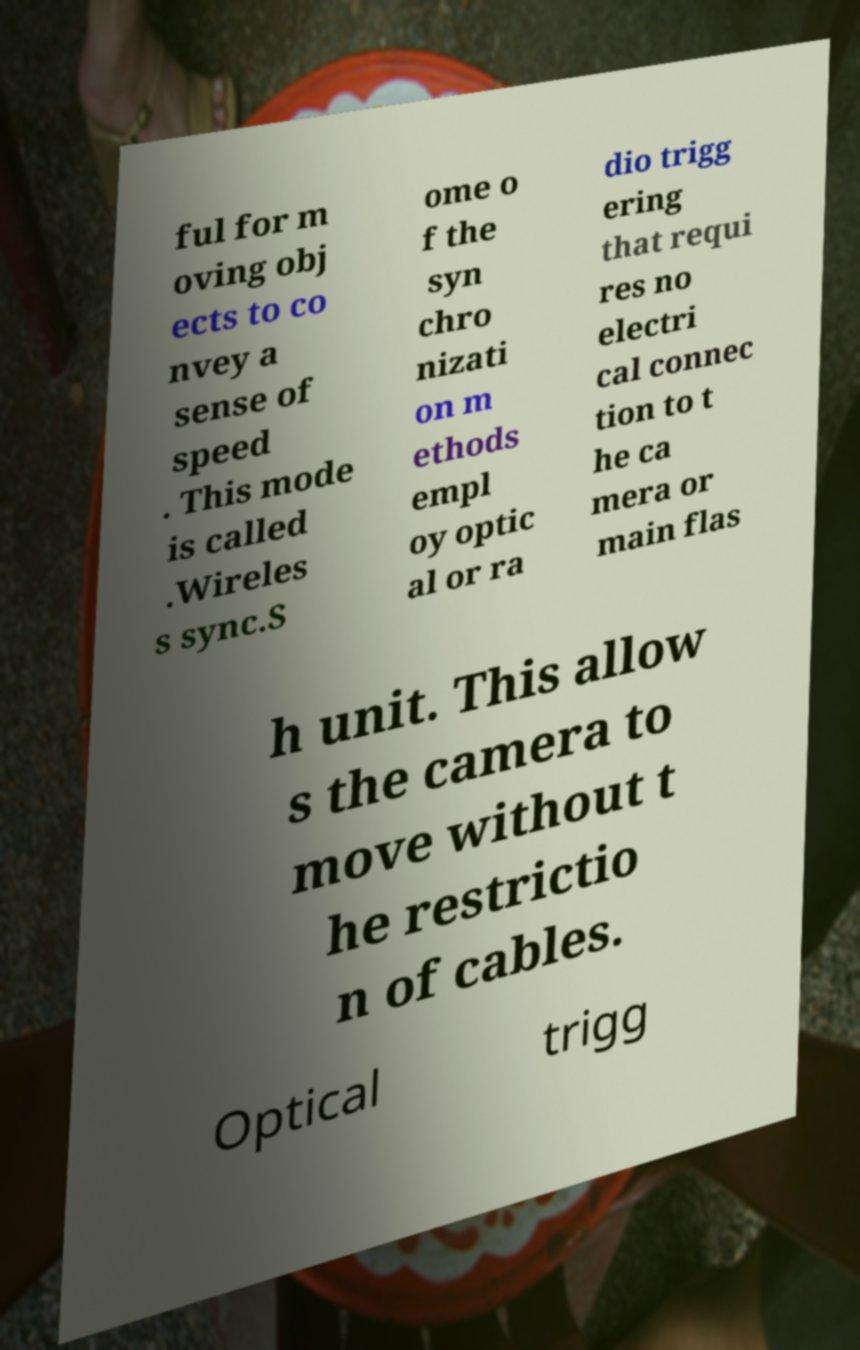There's text embedded in this image that I need extracted. Can you transcribe it verbatim? ful for m oving obj ects to co nvey a sense of speed . This mode is called .Wireles s sync.S ome o f the syn chro nizati on m ethods empl oy optic al or ra dio trigg ering that requi res no electri cal connec tion to t he ca mera or main flas h unit. This allow s the camera to move without t he restrictio n of cables. Optical trigg 